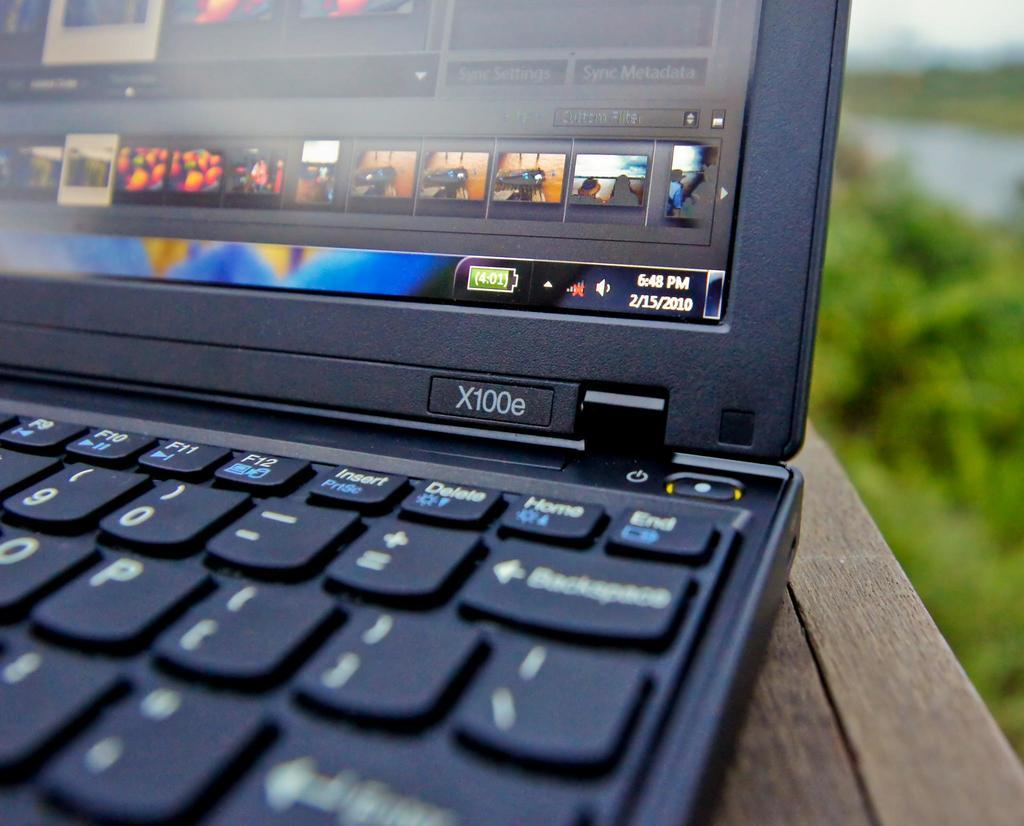<image>
Provide a brief description of the given image. An X100e laptop is open and shows that the date is 2/15/2010. 